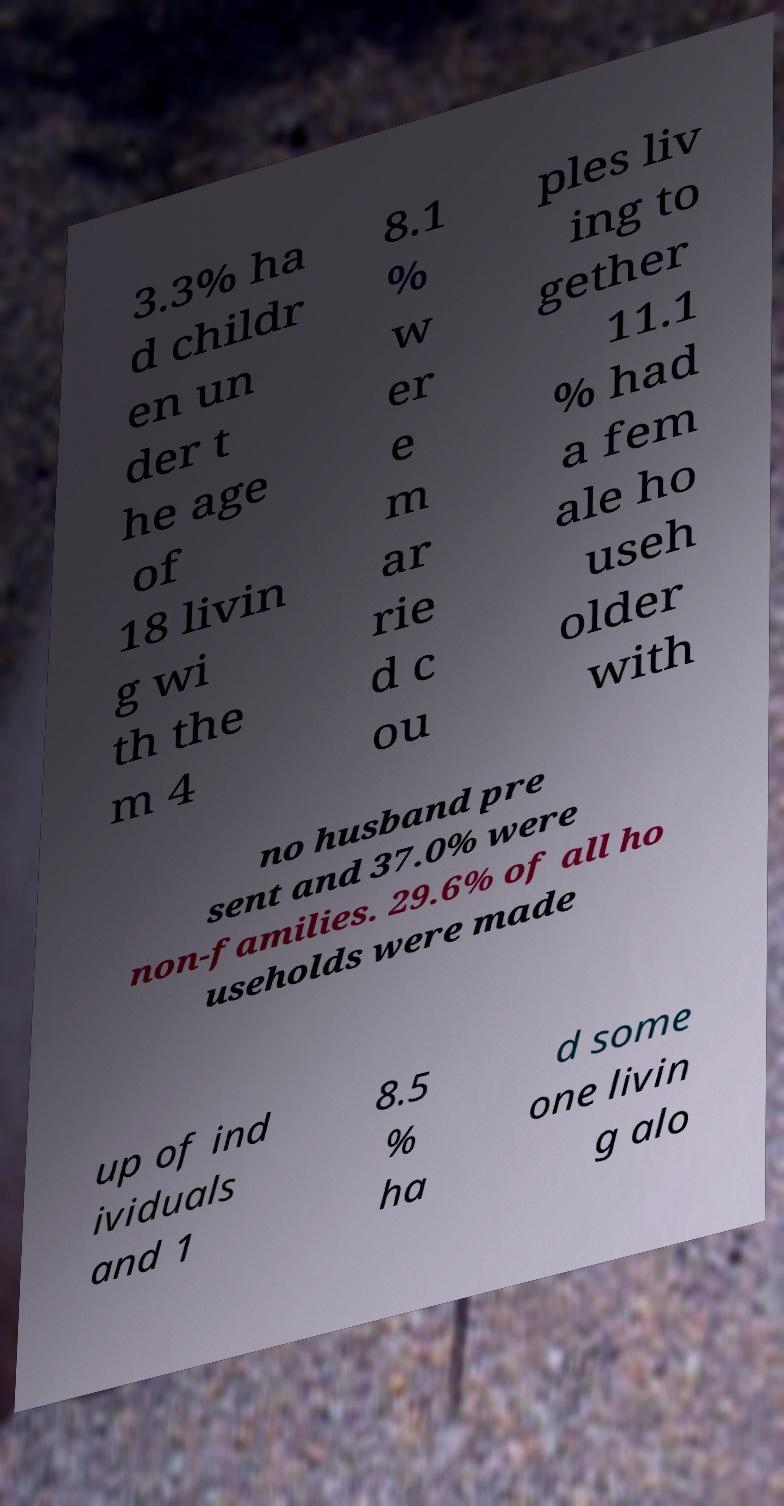Could you extract and type out the text from this image? 3.3% ha d childr en un der t he age of 18 livin g wi th the m 4 8.1 % w er e m ar rie d c ou ples liv ing to gether 11.1 % had a fem ale ho useh older with no husband pre sent and 37.0% were non-families. 29.6% of all ho useholds were made up of ind ividuals and 1 8.5 % ha d some one livin g alo 